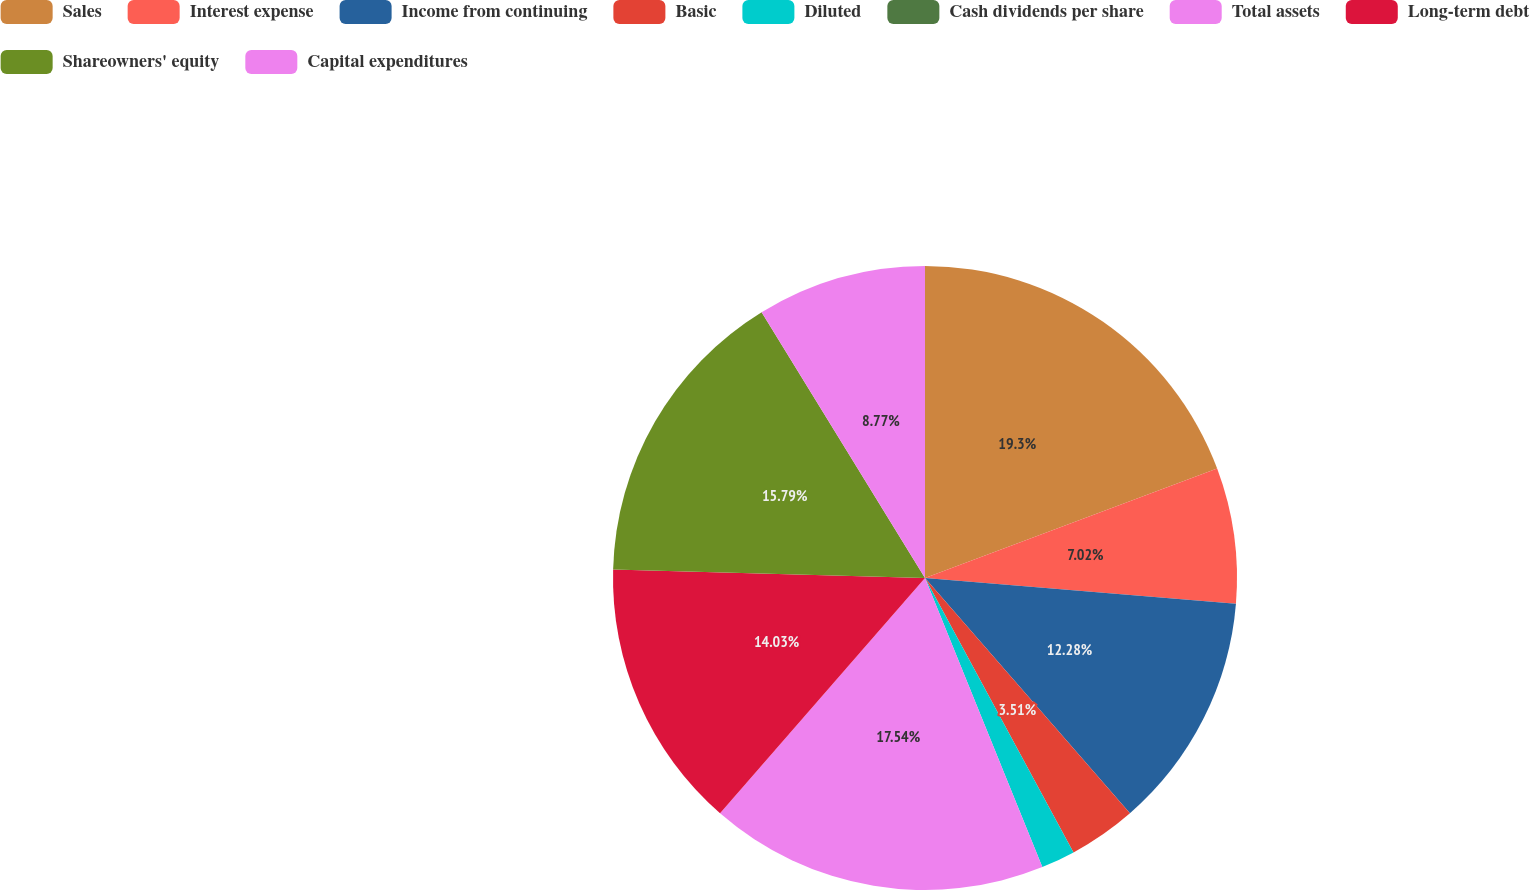Convert chart. <chart><loc_0><loc_0><loc_500><loc_500><pie_chart><fcel>Sales<fcel>Interest expense<fcel>Income from continuing<fcel>Basic<fcel>Diluted<fcel>Cash dividends per share<fcel>Total assets<fcel>Long-term debt<fcel>Shareowners' equity<fcel>Capital expenditures<nl><fcel>19.29%<fcel>7.02%<fcel>12.28%<fcel>3.51%<fcel>1.76%<fcel>0.0%<fcel>17.54%<fcel>14.03%<fcel>15.79%<fcel>8.77%<nl></chart> 